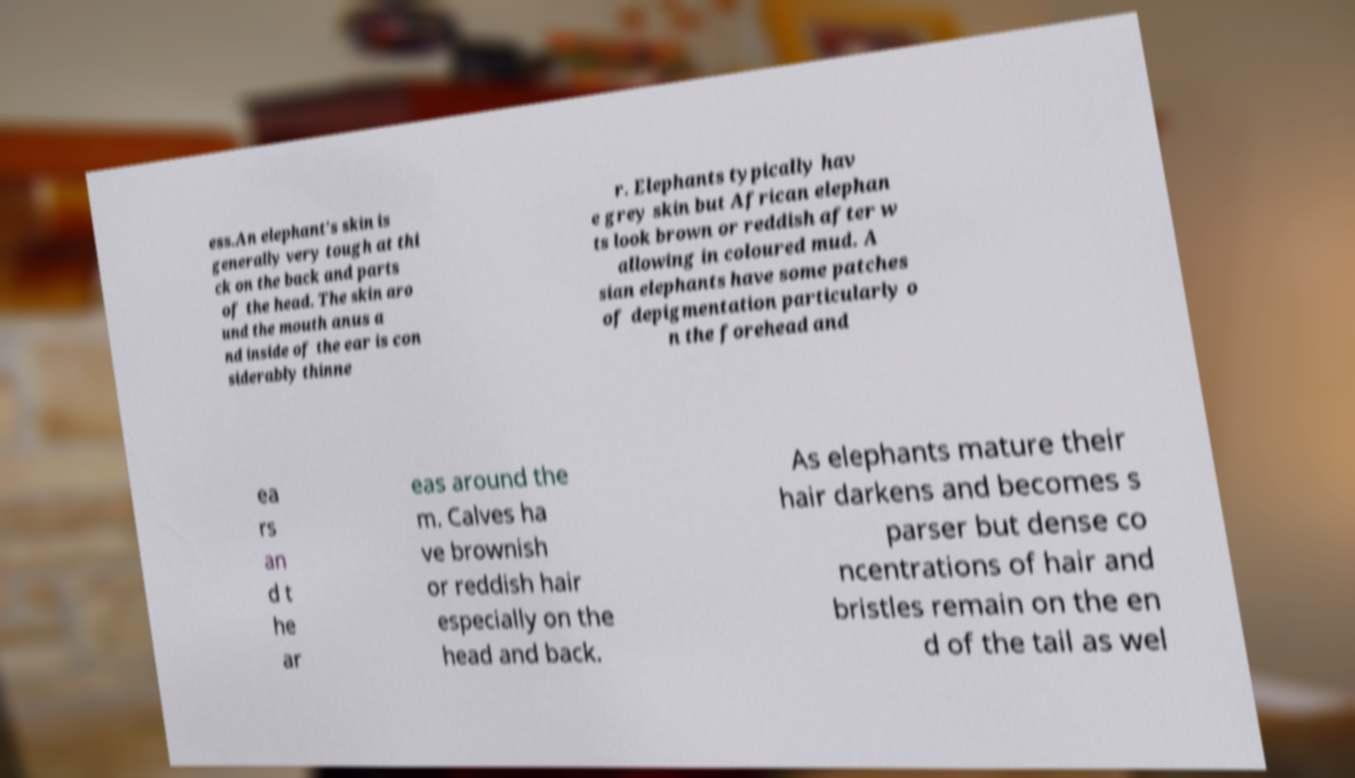I need the written content from this picture converted into text. Can you do that? ess.An elephant's skin is generally very tough at thi ck on the back and parts of the head. The skin aro und the mouth anus a nd inside of the ear is con siderably thinne r. Elephants typically hav e grey skin but African elephan ts look brown or reddish after w allowing in coloured mud. A sian elephants have some patches of depigmentation particularly o n the forehead and ea rs an d t he ar eas around the m. Calves ha ve brownish or reddish hair especially on the head and back. As elephants mature their hair darkens and becomes s parser but dense co ncentrations of hair and bristles remain on the en d of the tail as wel 